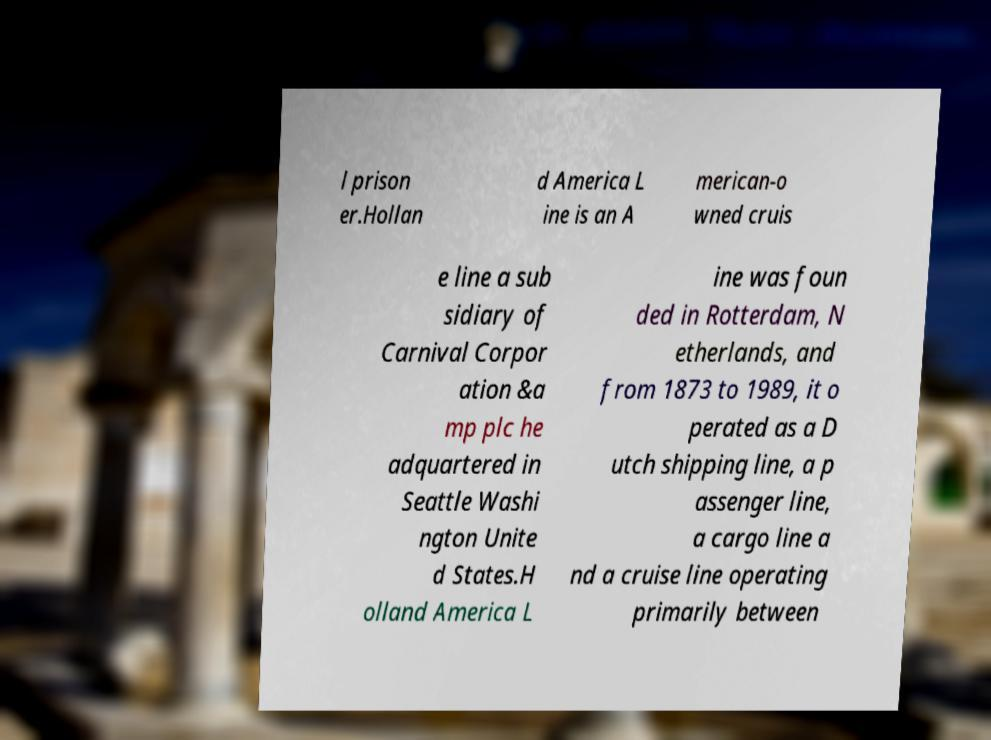Could you assist in decoding the text presented in this image and type it out clearly? l prison er.Hollan d America L ine is an A merican-o wned cruis e line a sub sidiary of Carnival Corpor ation &a mp plc he adquartered in Seattle Washi ngton Unite d States.H olland America L ine was foun ded in Rotterdam, N etherlands, and from 1873 to 1989, it o perated as a D utch shipping line, a p assenger line, a cargo line a nd a cruise line operating primarily between 